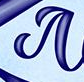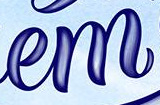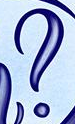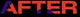Read the text content from these images in order, separated by a semicolon. #; em; ?; AFTER 